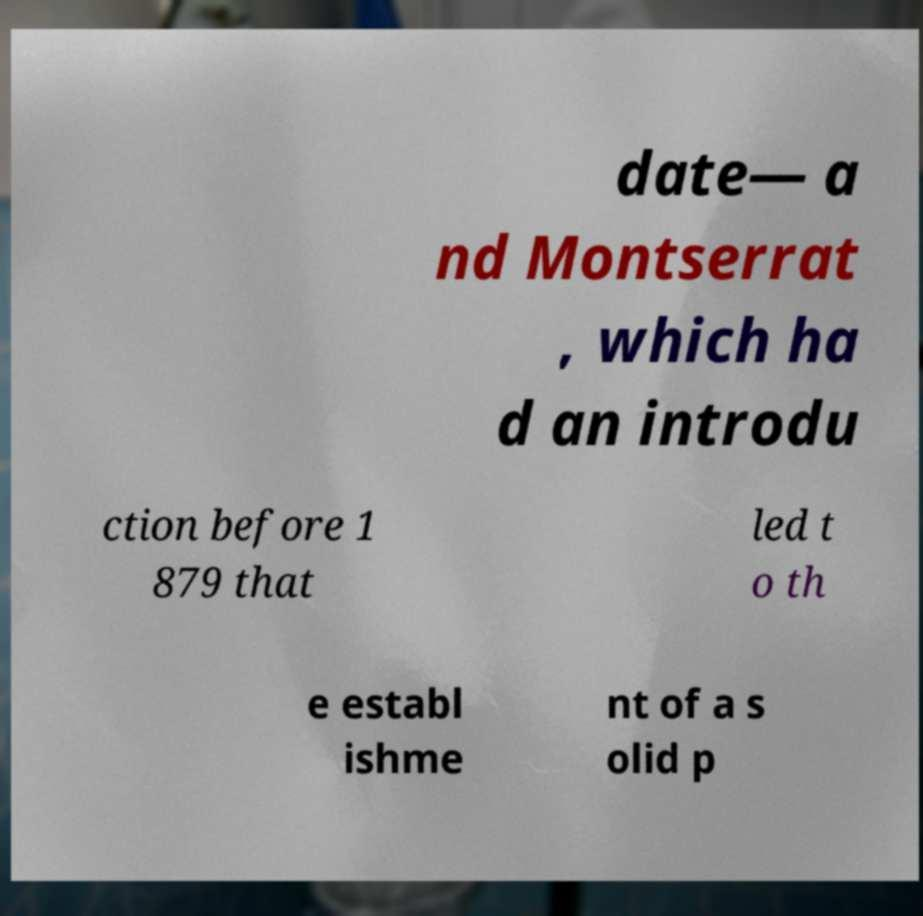I need the written content from this picture converted into text. Can you do that? date— a nd Montserrat , which ha d an introdu ction before 1 879 that led t o th e establ ishme nt of a s olid p 